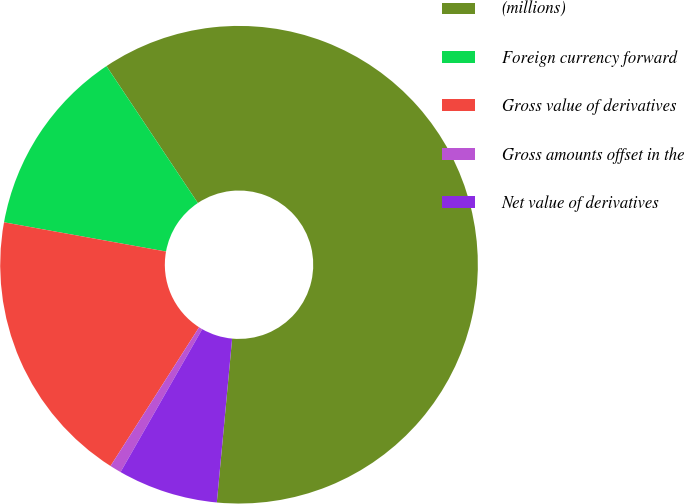Convert chart to OTSL. <chart><loc_0><loc_0><loc_500><loc_500><pie_chart><fcel>(millions)<fcel>Foreign currency forward<fcel>Gross value of derivatives<fcel>Gross amounts offset in the<fcel>Net value of derivatives<nl><fcel>60.85%<fcel>12.79%<fcel>18.8%<fcel>0.78%<fcel>6.78%<nl></chart> 